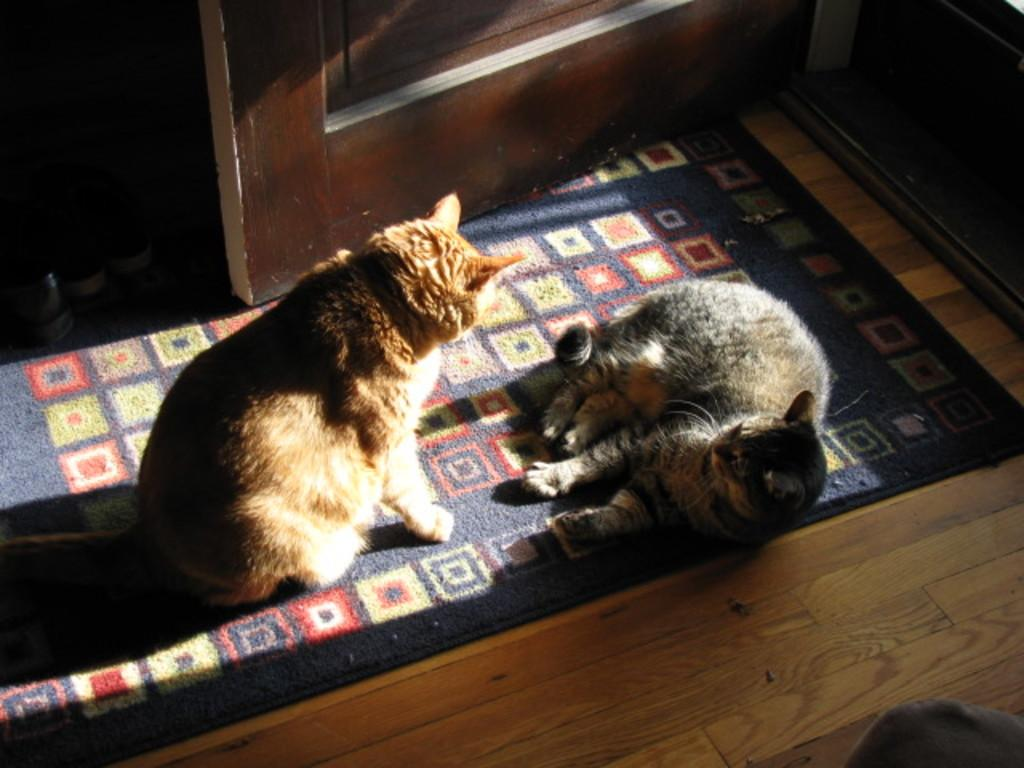How many cats can be seen in the image? There are two cats on a carpet in the image. Where is the carpet located? The carpet is on the floor. What can be seen in the background of the image? There is a door and shoes in the background of the image. What type of area might this scene be depicting? The scene appears to be an entrance. How many chickens are present in the image? There are no chickens present in the image; it features two cats on a carpet. What country is depicted in the image? The image does not depict a specific country; it shows a scene with cats, a carpet, and a door. 